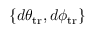<formula> <loc_0><loc_0><loc_500><loc_500>\{ d \theta _ { t r } , d \phi _ { t r } \}</formula> 